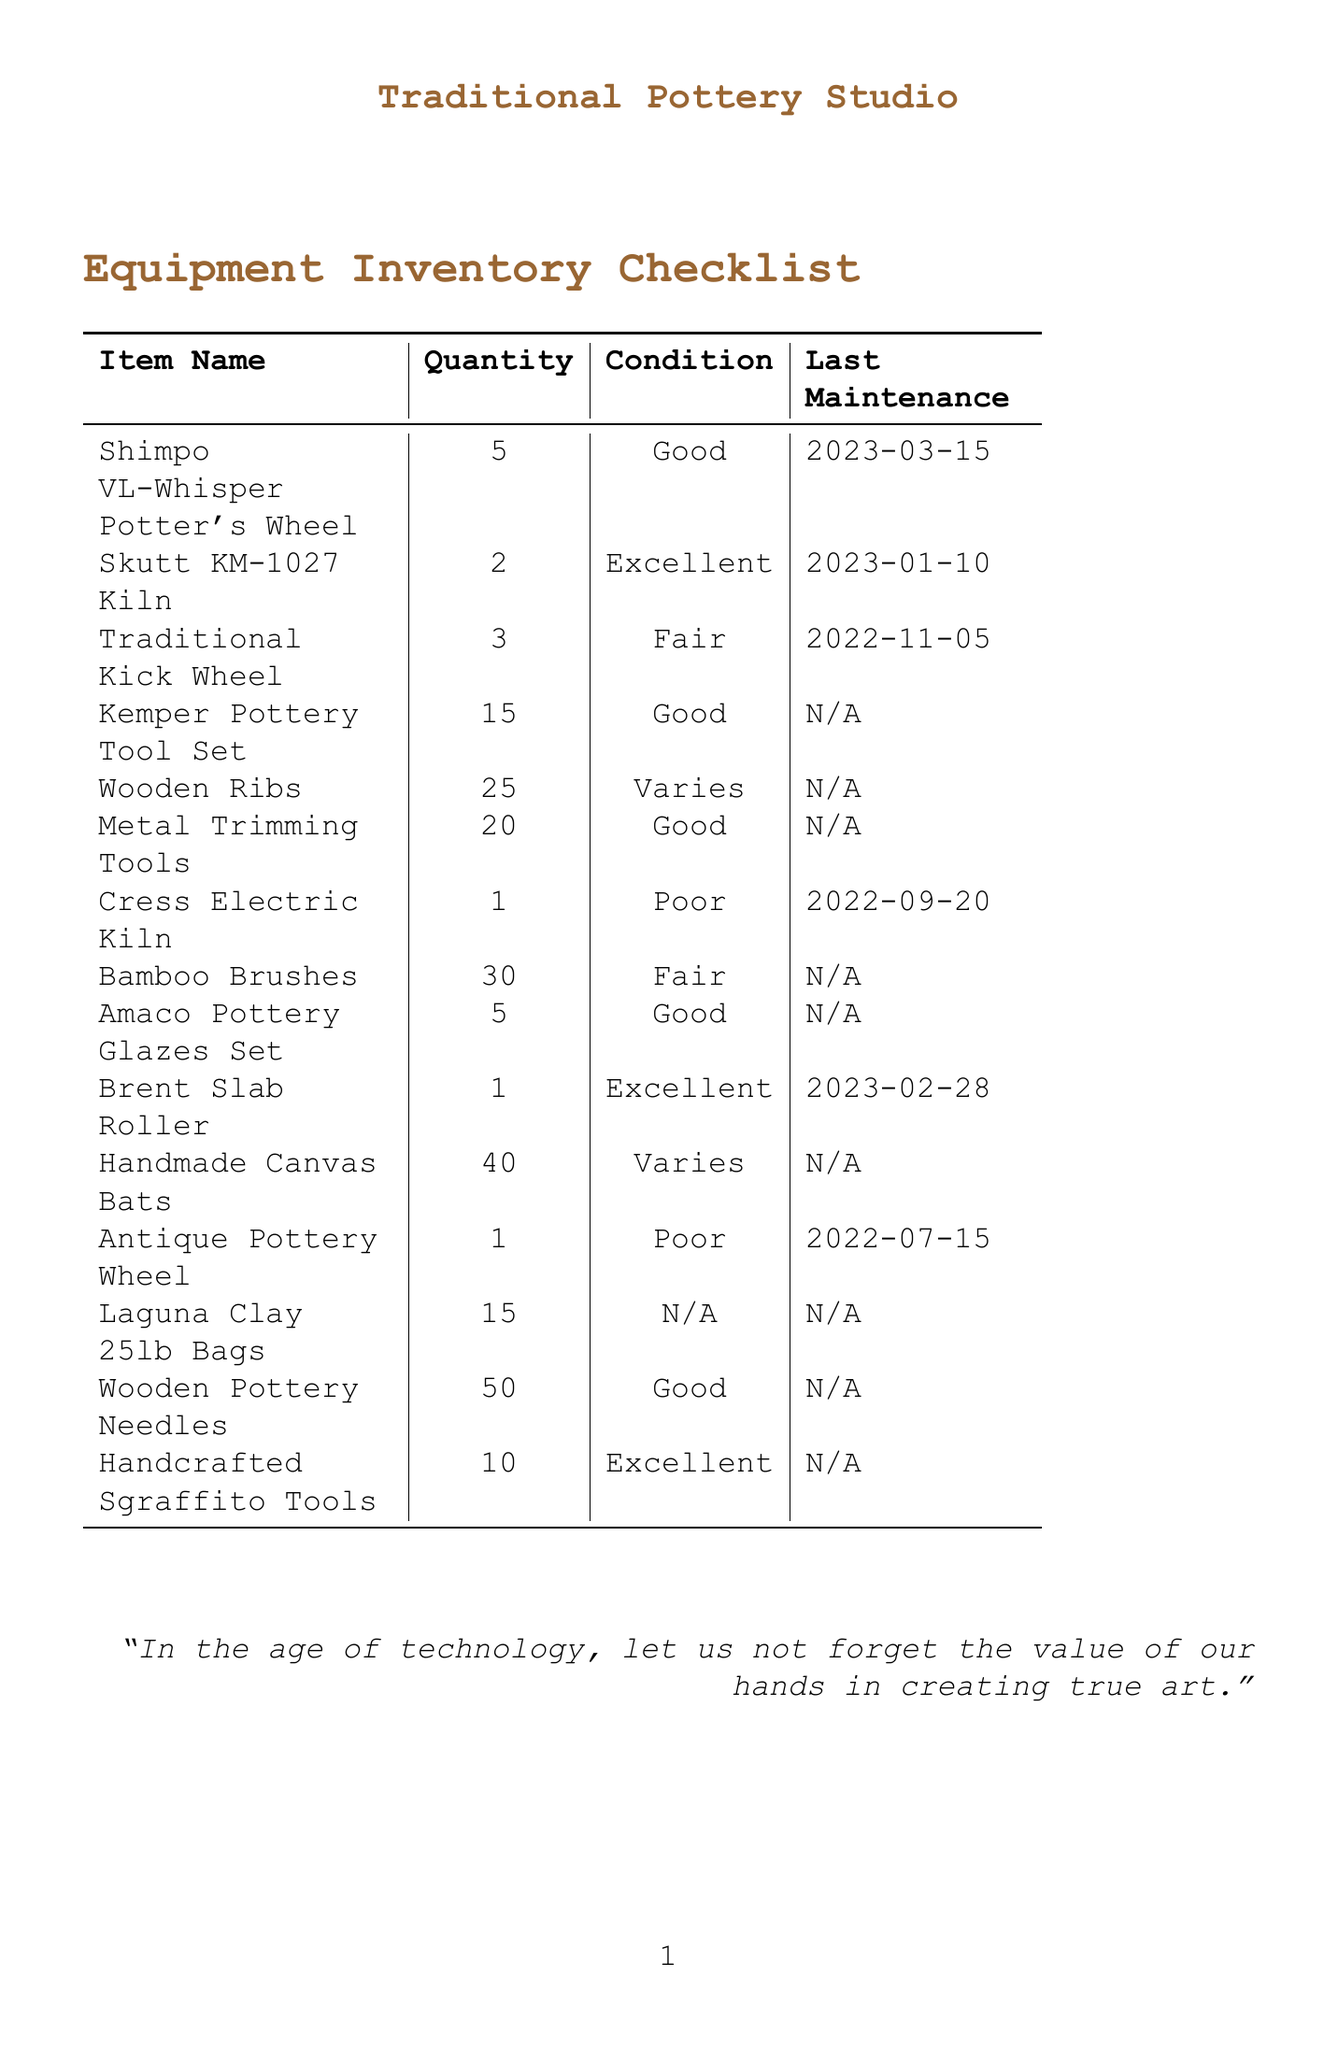What is the item name with the highest quantity? The highest quantity is for Wooden Pottery Needles, which has 50 units listed in the document.
Answer: Wooden Pottery Needles What is the condition of the Skutt KM-1027 Kiln? The condition of the Skutt KM-1027 Kiln, based on the document, is "Excellent."
Answer: Excellent How many Antique Pottery Wheels are listed? The document states that there is 1 Antique Pottery Wheel that is listed in the inventory.
Answer: 1 When was the last maintenance date for the Cress Electric Kiln? The last maintenance date for the Cress Electric Kiln, as indicated in the document, is 2022-09-20.
Answer: 2022-09-20 How many items are in "Fair" condition? A total of 3 items are in "Fair" condition, specifically the Traditional Kick Wheel, Bamboo Brushes, and the Cress Electric Kiln.
Answer: 3 Which item has not undergone maintenance? According to the document, both the Kemper Pottery Tool Set and the Bamboo Brushes have not undergone maintenance, as their last maintenance dates are marked as "N/A."
Answer: Kemper Pottery Tool Set What is the quantity of the item with the condition "Poor"? The document shows that there are 1 Cress Electric Kiln and 1 Antique Pottery Wheel that are both in "Poor" condition.
Answer: 1 What is the total quantity of Wooden Ribs available? The total quantity of Wooden Ribs available, as per the inventory, is 25.
Answer: 25 How many items are categorized under "Excellent" condition? Based on the document, there are 3 items categorized as "Excellent," namely Skutt KM-1027 Kiln, Brent Slab Roller, and Handcrafted Sgraffito Tools.
Answer: 3 